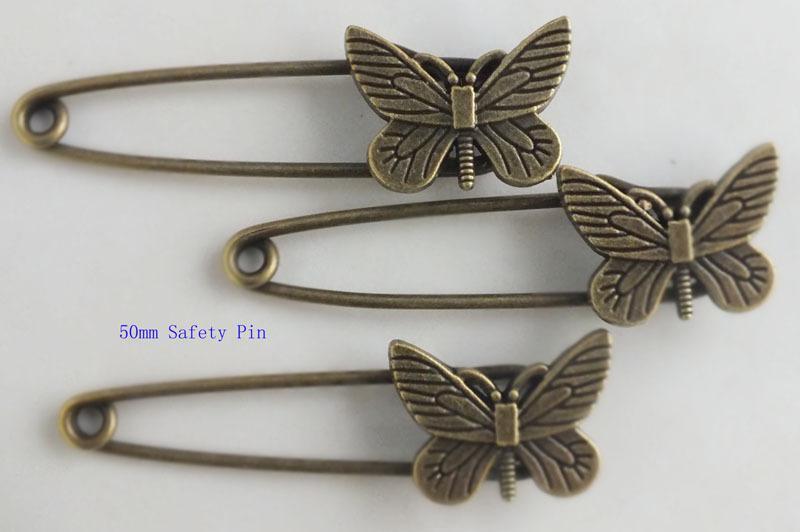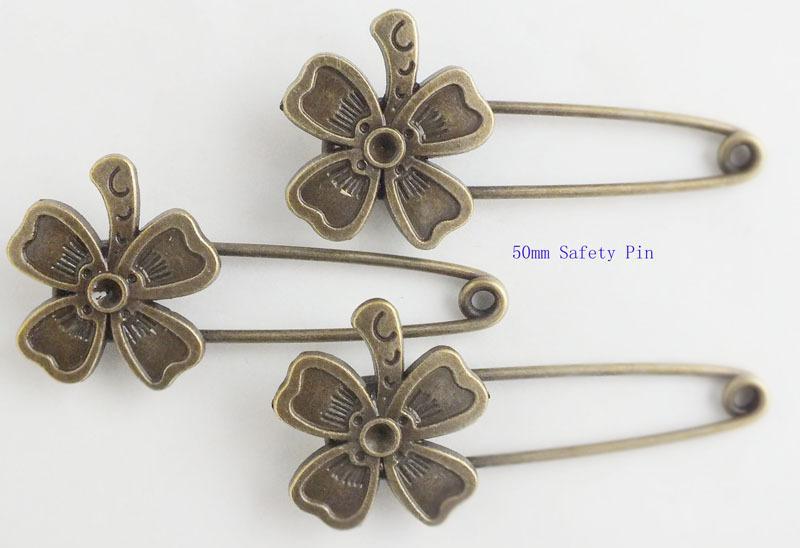The first image is the image on the left, the second image is the image on the right. For the images shown, is this caption "An image shows pins arranged like spokes forming a circle." true? Answer yes or no. No. 